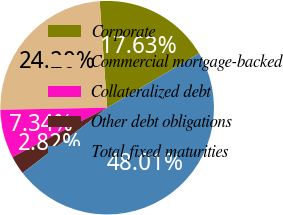<chart> <loc_0><loc_0><loc_500><loc_500><pie_chart><fcel>Corporate<fcel>Commercial mortgage-backed<fcel>Collateralized debt<fcel>Other debt obligations<fcel>Total fixed maturities<nl><fcel>17.63%<fcel>24.2%<fcel>7.34%<fcel>2.82%<fcel>48.01%<nl></chart> 